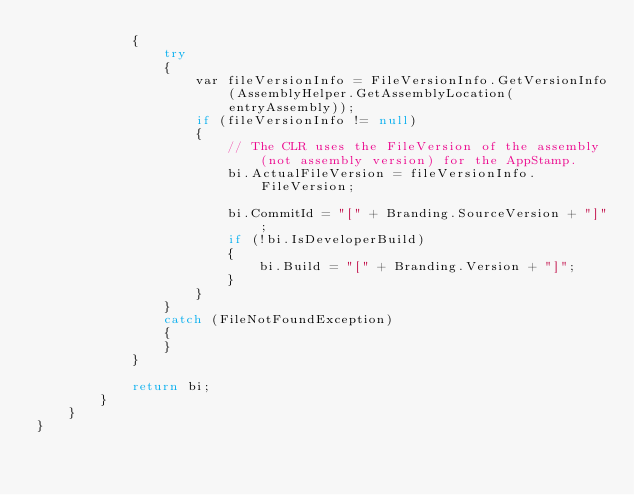<code> <loc_0><loc_0><loc_500><loc_500><_C#_>            {
                try
                {
                    var fileVersionInfo = FileVersionInfo.GetVersionInfo(AssemblyHelper.GetAssemblyLocation(entryAssembly));
                    if (fileVersionInfo != null)
                    {
                        // The CLR uses the FileVersion of the assembly (not assembly version) for the AppStamp.
                        bi.ActualFileVersion = fileVersionInfo.FileVersion;

                        bi.CommitId = "[" + Branding.SourceVersion + "]";
                        if (!bi.IsDeveloperBuild)
                        {
                            bi.Build = "[" + Branding.Version + "]";
                        }
                    }
                }
                catch (FileNotFoundException)
                {
                }
            }

            return bi;
        }
    }
}
</code> 